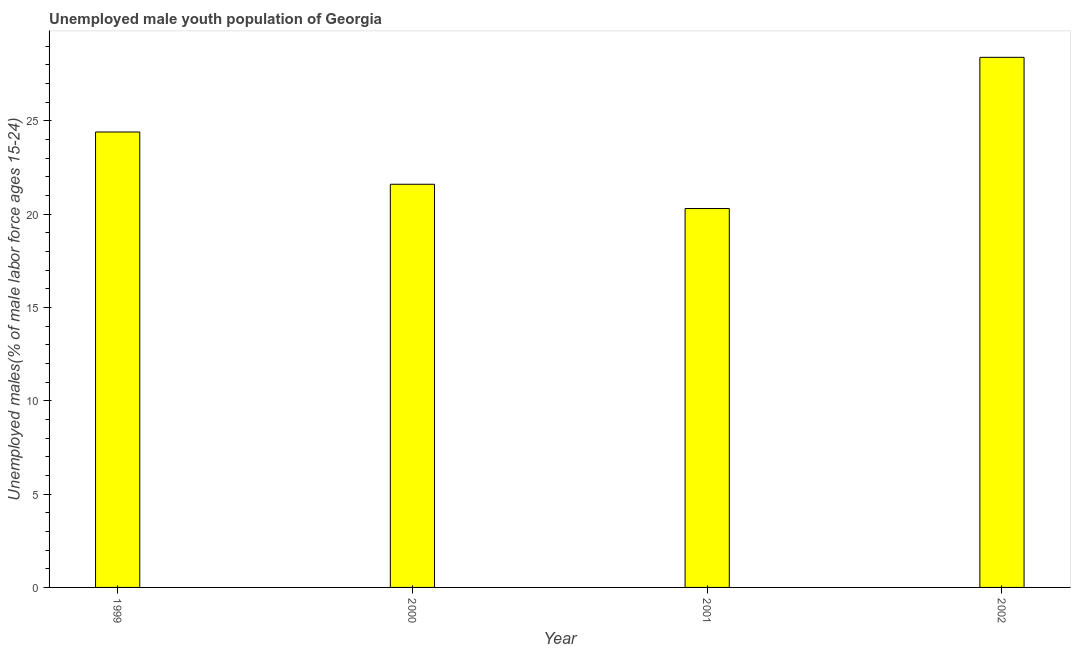Does the graph contain any zero values?
Offer a terse response. No. What is the title of the graph?
Make the answer very short. Unemployed male youth population of Georgia. What is the label or title of the Y-axis?
Your answer should be very brief. Unemployed males(% of male labor force ages 15-24). What is the unemployed male youth in 2002?
Offer a terse response. 28.4. Across all years, what is the maximum unemployed male youth?
Provide a succinct answer. 28.4. Across all years, what is the minimum unemployed male youth?
Your answer should be compact. 20.3. In which year was the unemployed male youth minimum?
Keep it short and to the point. 2001. What is the sum of the unemployed male youth?
Offer a terse response. 94.7. What is the average unemployed male youth per year?
Keep it short and to the point. 23.68. What is the ratio of the unemployed male youth in 2000 to that in 2001?
Make the answer very short. 1.06. Is the difference between the unemployed male youth in 1999 and 2002 greater than the difference between any two years?
Your answer should be very brief. No. Is the sum of the unemployed male youth in 2000 and 2001 greater than the maximum unemployed male youth across all years?
Provide a succinct answer. Yes. What is the difference between the highest and the lowest unemployed male youth?
Your response must be concise. 8.1. What is the Unemployed males(% of male labor force ages 15-24) of 1999?
Ensure brevity in your answer.  24.4. What is the Unemployed males(% of male labor force ages 15-24) of 2000?
Make the answer very short. 21.6. What is the Unemployed males(% of male labor force ages 15-24) in 2001?
Offer a very short reply. 20.3. What is the Unemployed males(% of male labor force ages 15-24) of 2002?
Your response must be concise. 28.4. What is the difference between the Unemployed males(% of male labor force ages 15-24) in 1999 and 2000?
Give a very brief answer. 2.8. What is the difference between the Unemployed males(% of male labor force ages 15-24) in 1999 and 2001?
Make the answer very short. 4.1. What is the difference between the Unemployed males(% of male labor force ages 15-24) in 1999 and 2002?
Keep it short and to the point. -4. What is the difference between the Unemployed males(% of male labor force ages 15-24) in 2000 and 2002?
Offer a terse response. -6.8. What is the difference between the Unemployed males(% of male labor force ages 15-24) in 2001 and 2002?
Your answer should be compact. -8.1. What is the ratio of the Unemployed males(% of male labor force ages 15-24) in 1999 to that in 2000?
Offer a very short reply. 1.13. What is the ratio of the Unemployed males(% of male labor force ages 15-24) in 1999 to that in 2001?
Provide a succinct answer. 1.2. What is the ratio of the Unemployed males(% of male labor force ages 15-24) in 1999 to that in 2002?
Offer a terse response. 0.86. What is the ratio of the Unemployed males(% of male labor force ages 15-24) in 2000 to that in 2001?
Provide a succinct answer. 1.06. What is the ratio of the Unemployed males(% of male labor force ages 15-24) in 2000 to that in 2002?
Provide a short and direct response. 0.76. What is the ratio of the Unemployed males(% of male labor force ages 15-24) in 2001 to that in 2002?
Ensure brevity in your answer.  0.71. 